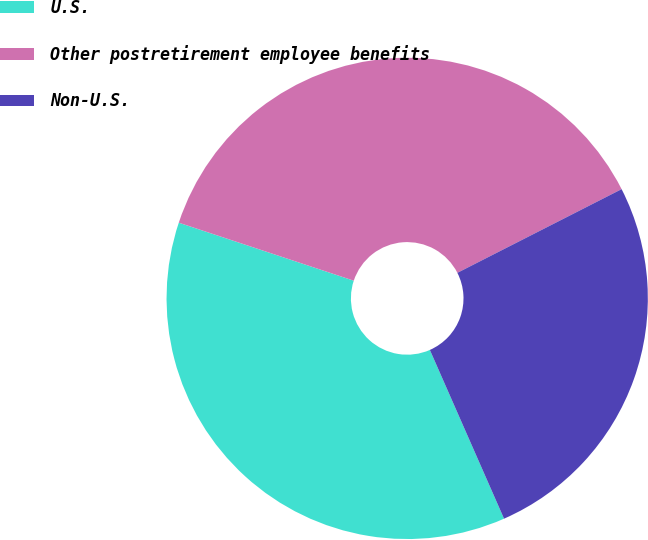Convert chart. <chart><loc_0><loc_0><loc_500><loc_500><pie_chart><fcel>U.S.<fcel>Other postretirement employee benefits<fcel>Non-U.S.<nl><fcel>36.69%<fcel>37.41%<fcel>25.91%<nl></chart> 